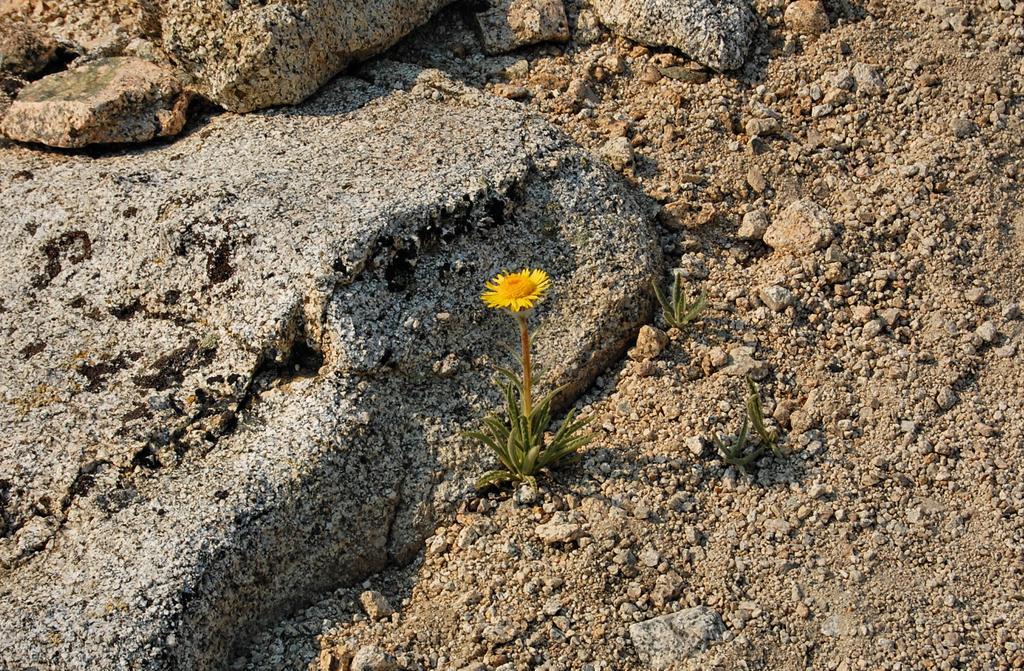Please provide a concise description of this image. In this image we can see a few plants and there is a flower and we can see some rocks and soil on the ground. 